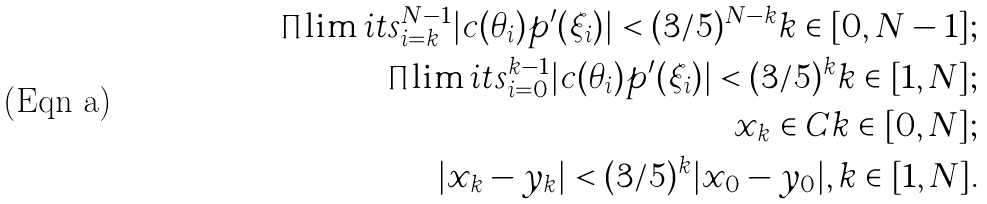Convert formula to latex. <formula><loc_0><loc_0><loc_500><loc_500>\prod \lim i t s ^ { N - 1 } _ { i = k } | c ( \theta _ { i } ) p ^ { \prime } ( \xi _ { i } ) | < ( 3 / 5 ) ^ { N - k } k \in [ 0 , N - 1 ] ; \\ \prod \lim i t s ^ { k - 1 } _ { i = 0 } | c ( \theta _ { i } ) p ^ { \prime } ( \xi _ { i } ) | < ( 3 / 5 ) ^ { k } k \in [ 1 , N ] ; \\ x _ { k } \in C k \in [ 0 , N ] ; \\ | x _ { k } - y _ { k } | < ( 3 / 5 ) ^ { k } | x _ { 0 } - y _ { 0 } | , k \in [ 1 , N ] .</formula> 